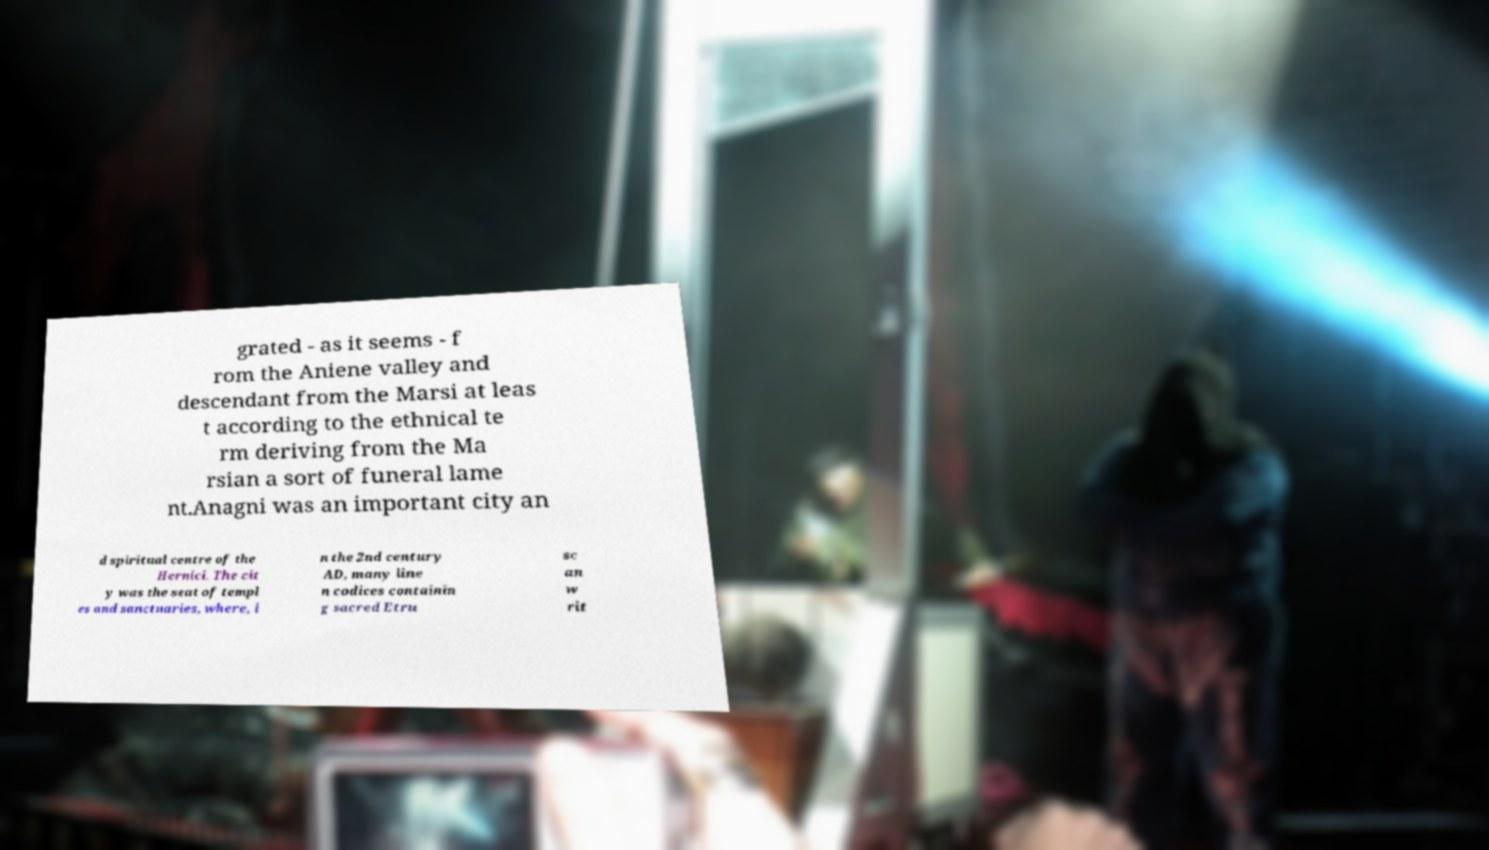Could you assist in decoding the text presented in this image and type it out clearly? grated - as it seems - f rom the Aniene valley and descendant from the Marsi at leas t according to the ethnical te rm deriving from the Ma rsian a sort of funeral lame nt.Anagni was an important city an d spiritual centre of the Hernici. The cit y was the seat of templ es and sanctuaries, where, i n the 2nd century AD, many line n codices containin g sacred Etru sc an w rit 